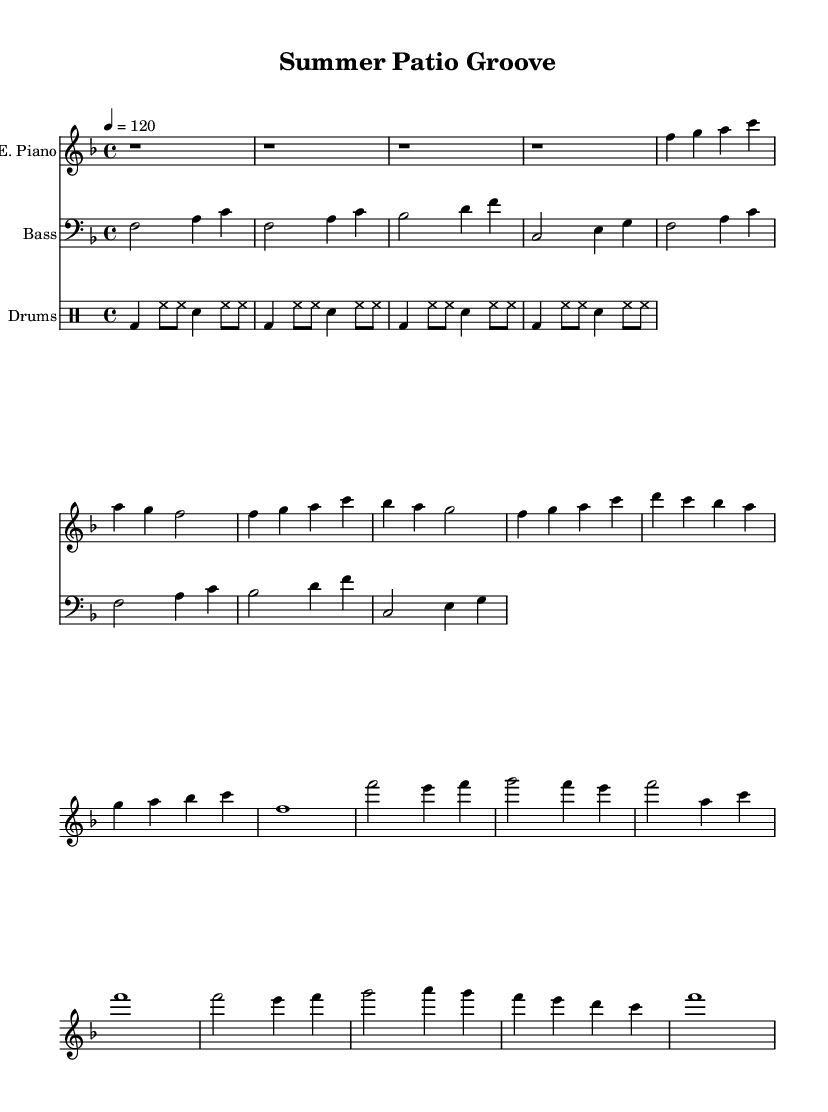What is the key signature of this music? The key signature is F major, which has one flat (B flat).
Answer: F major What is the time signature of the piece? The time signature is 4/4, indicating four beats per measure.
Answer: 4/4 What is the tempo of the piece? The tempo is marked at quarter note = 120 beats per minute, which indicates a moderate pace.
Answer: 120 How many measures are in the verse section? The verse section consists of eight measures, as counted from the first verse to the last.
Answer: 8 measures What instruments are used in this score? The score includes an Electric Piano, Bass, and Drums, as indicated by their corresponding staves.
Answer: Electric Piano, Bass, Drums What rhythmic pattern is used for the drums? The drum pattern features a combination of bass drum, hi-hats, and snare drum in a consistent repeating pattern throughout.
Answer: Bass, hi-hats, snare How does the bass line relate to the melody? The bass line generally supports the melody, providing a harmonic foundation and rhythmic drive that complements the higher notes played by the electric piano.
Answer: Harmonic foundation 